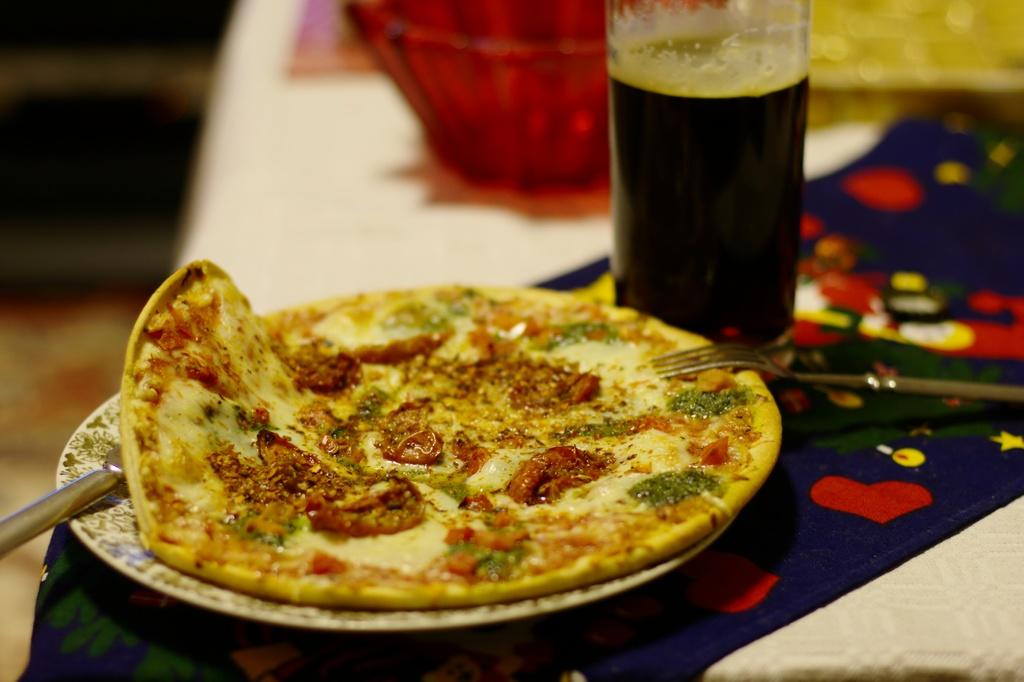What is on the plate in the image? There is pizza on the plate, and there is a knife on the plate as well. What other utensils are present in the image? There is a fork on the table. What type of dish is on the table besides the plate? There is a bowl on the table. What else can be seen on the table? There are other objects on the table. How does the mailbox contribute to the prose in the image? There is no mailbox present in the image, and therefore it cannot contribute to any prose. 